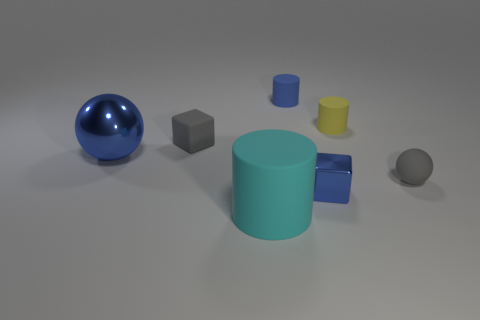Does the rubber block have the same color as the tiny ball?
Provide a short and direct response. Yes. How many cubes are either big red shiny objects or tiny yellow things?
Offer a terse response. 0. Are any tiny brown balls visible?
Provide a short and direct response. No. What is the size of the cyan thing that is the same shape as the tiny yellow thing?
Your response must be concise. Large. What is the shape of the rubber thing that is in front of the gray object that is right of the small blue cylinder?
Give a very brief answer. Cylinder. How many gray objects are big objects or tiny matte cylinders?
Your answer should be compact. 0. What color is the rubber cube?
Offer a terse response. Gray. Do the cyan matte cylinder and the blue cube have the same size?
Your answer should be very brief. No. Is there any other thing that is the same shape as the tiny yellow matte thing?
Your answer should be compact. Yes. Does the big cyan object have the same material as the blue thing behind the large shiny object?
Make the answer very short. Yes. 